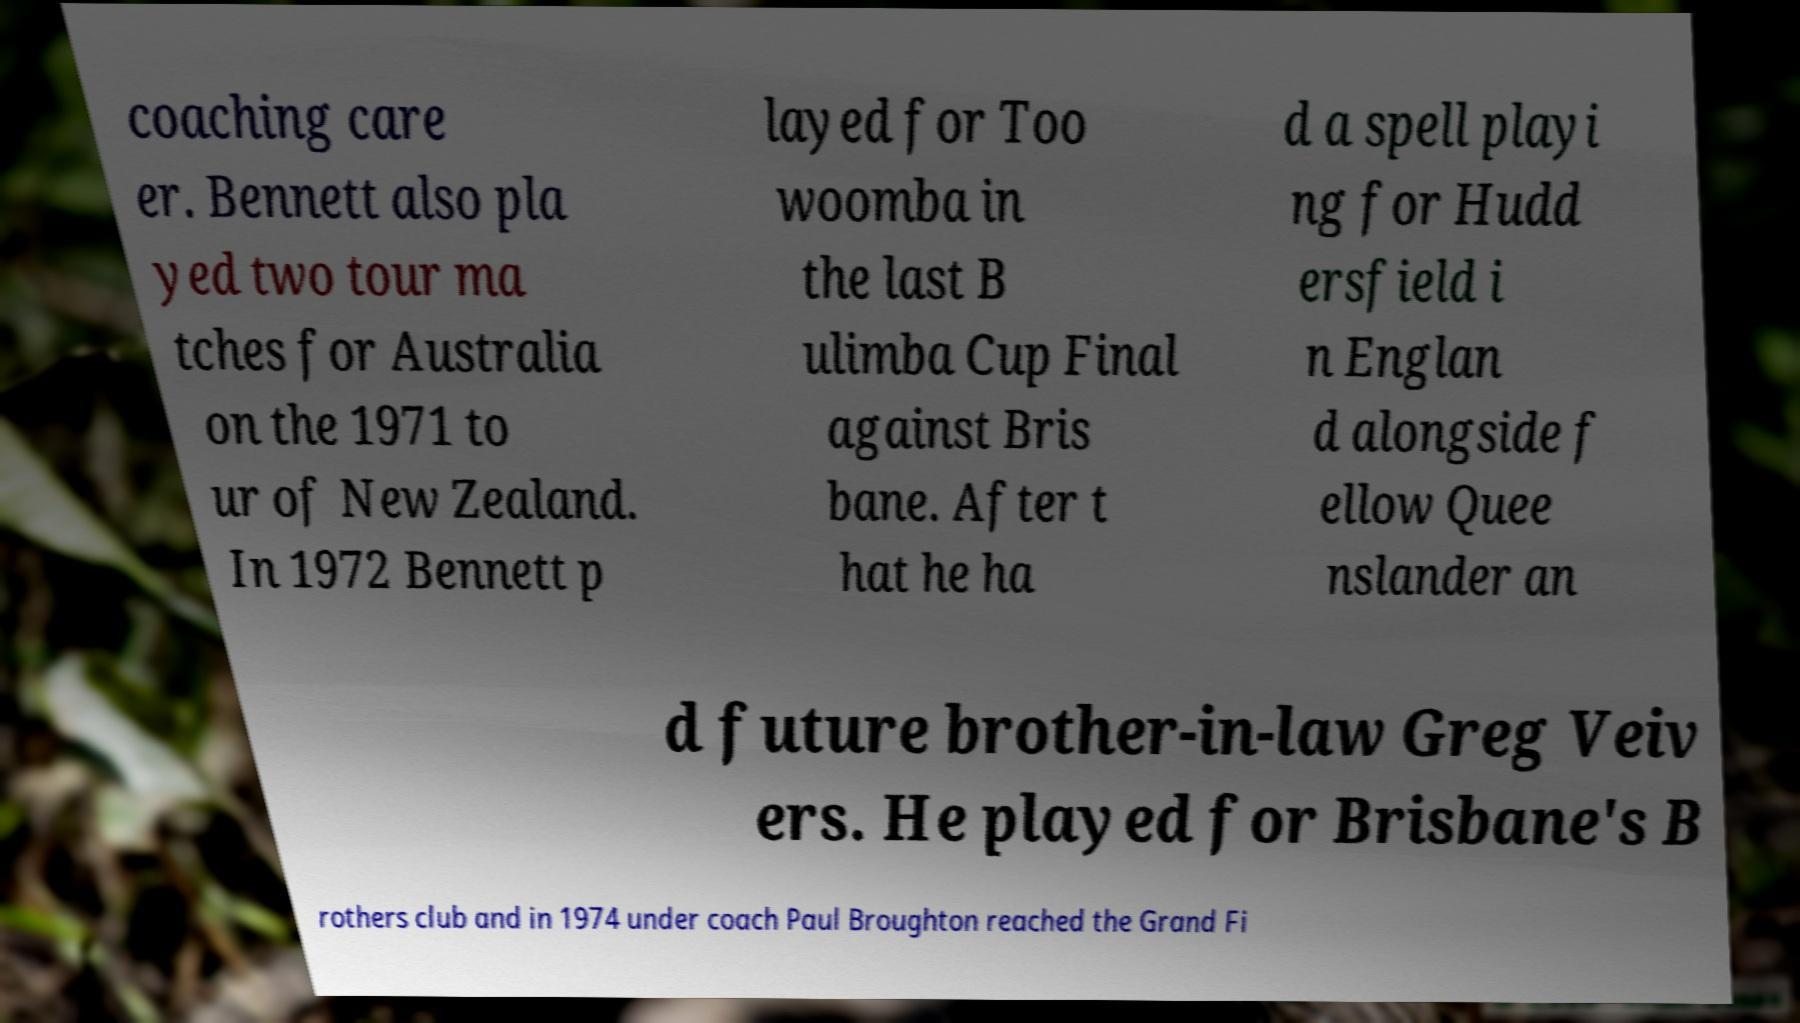There's text embedded in this image that I need extracted. Can you transcribe it verbatim? coaching care er. Bennett also pla yed two tour ma tches for Australia on the 1971 to ur of New Zealand. In 1972 Bennett p layed for Too woomba in the last B ulimba Cup Final against Bris bane. After t hat he ha d a spell playi ng for Hudd ersfield i n Englan d alongside f ellow Quee nslander an d future brother-in-law Greg Veiv ers. He played for Brisbane's B rothers club and in 1974 under coach Paul Broughton reached the Grand Fi 